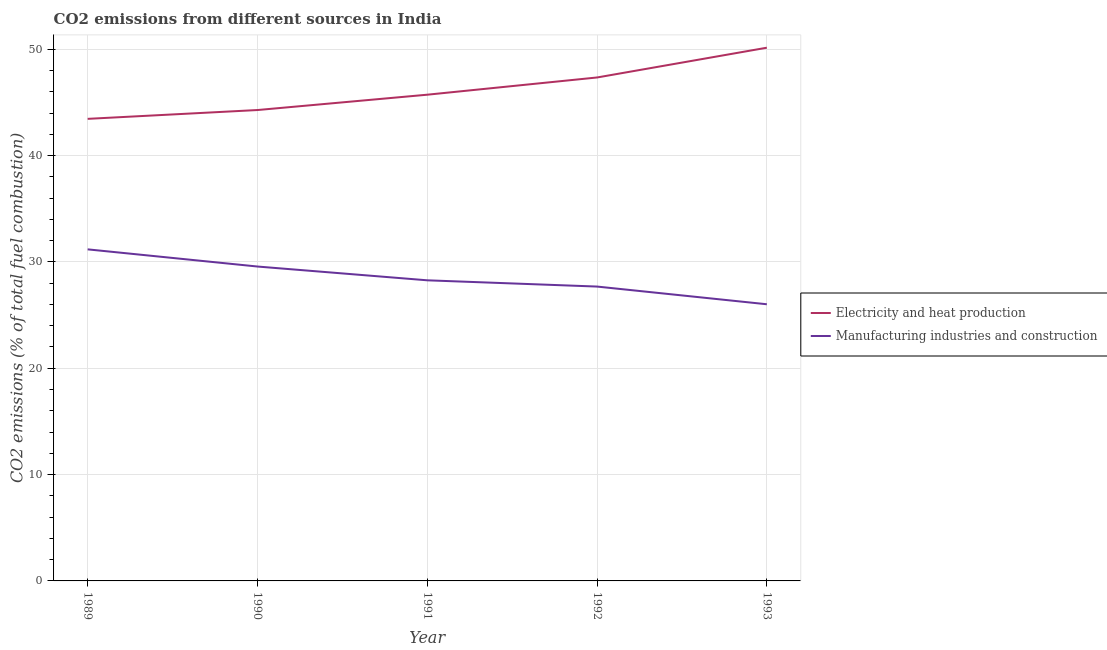How many different coloured lines are there?
Offer a terse response. 2. Does the line corresponding to co2 emissions due to electricity and heat production intersect with the line corresponding to co2 emissions due to manufacturing industries?
Your answer should be compact. No. Is the number of lines equal to the number of legend labels?
Ensure brevity in your answer.  Yes. What is the co2 emissions due to manufacturing industries in 1990?
Keep it short and to the point. 29.57. Across all years, what is the maximum co2 emissions due to electricity and heat production?
Make the answer very short. 50.15. Across all years, what is the minimum co2 emissions due to electricity and heat production?
Provide a succinct answer. 43.46. In which year was the co2 emissions due to electricity and heat production maximum?
Provide a succinct answer. 1993. In which year was the co2 emissions due to manufacturing industries minimum?
Keep it short and to the point. 1993. What is the total co2 emissions due to manufacturing industries in the graph?
Keep it short and to the point. 142.72. What is the difference between the co2 emissions due to manufacturing industries in 1989 and that in 1993?
Give a very brief answer. 5.16. What is the difference between the co2 emissions due to electricity and heat production in 1991 and the co2 emissions due to manufacturing industries in 1989?
Your answer should be very brief. 14.54. What is the average co2 emissions due to manufacturing industries per year?
Offer a terse response. 28.54. In the year 1993, what is the difference between the co2 emissions due to electricity and heat production and co2 emissions due to manufacturing industries?
Keep it short and to the point. 24.13. In how many years, is the co2 emissions due to electricity and heat production greater than 6 %?
Keep it short and to the point. 5. What is the ratio of the co2 emissions due to manufacturing industries in 1989 to that in 1991?
Offer a terse response. 1.1. Is the co2 emissions due to manufacturing industries in 1991 less than that in 1993?
Provide a short and direct response. No. Is the difference between the co2 emissions due to manufacturing industries in 1991 and 1993 greater than the difference between the co2 emissions due to electricity and heat production in 1991 and 1993?
Ensure brevity in your answer.  Yes. What is the difference between the highest and the second highest co2 emissions due to electricity and heat production?
Your answer should be very brief. 2.8. What is the difference between the highest and the lowest co2 emissions due to manufacturing industries?
Provide a short and direct response. 5.16. Is the sum of the co2 emissions due to electricity and heat production in 1990 and 1991 greater than the maximum co2 emissions due to manufacturing industries across all years?
Offer a very short reply. Yes. Is the co2 emissions due to electricity and heat production strictly greater than the co2 emissions due to manufacturing industries over the years?
Offer a terse response. Yes. How many lines are there?
Offer a very short reply. 2. What is the difference between two consecutive major ticks on the Y-axis?
Your answer should be very brief. 10. Are the values on the major ticks of Y-axis written in scientific E-notation?
Your response must be concise. No. Does the graph contain any zero values?
Your answer should be very brief. No. Where does the legend appear in the graph?
Ensure brevity in your answer.  Center right. How are the legend labels stacked?
Your answer should be compact. Vertical. What is the title of the graph?
Provide a succinct answer. CO2 emissions from different sources in India. Does "Old" appear as one of the legend labels in the graph?
Your answer should be compact. No. What is the label or title of the Y-axis?
Offer a very short reply. CO2 emissions (% of total fuel combustion). What is the CO2 emissions (% of total fuel combustion) in Electricity and heat production in 1989?
Your answer should be compact. 43.46. What is the CO2 emissions (% of total fuel combustion) in Manufacturing industries and construction in 1989?
Your answer should be very brief. 31.18. What is the CO2 emissions (% of total fuel combustion) of Electricity and heat production in 1990?
Make the answer very short. 44.28. What is the CO2 emissions (% of total fuel combustion) of Manufacturing industries and construction in 1990?
Provide a succinct answer. 29.57. What is the CO2 emissions (% of total fuel combustion) of Electricity and heat production in 1991?
Offer a terse response. 45.73. What is the CO2 emissions (% of total fuel combustion) of Manufacturing industries and construction in 1991?
Your answer should be compact. 28.27. What is the CO2 emissions (% of total fuel combustion) in Electricity and heat production in 1992?
Provide a short and direct response. 47.35. What is the CO2 emissions (% of total fuel combustion) in Manufacturing industries and construction in 1992?
Provide a short and direct response. 27.68. What is the CO2 emissions (% of total fuel combustion) in Electricity and heat production in 1993?
Offer a terse response. 50.15. What is the CO2 emissions (% of total fuel combustion) of Manufacturing industries and construction in 1993?
Your answer should be compact. 26.02. Across all years, what is the maximum CO2 emissions (% of total fuel combustion) in Electricity and heat production?
Give a very brief answer. 50.15. Across all years, what is the maximum CO2 emissions (% of total fuel combustion) in Manufacturing industries and construction?
Your response must be concise. 31.18. Across all years, what is the minimum CO2 emissions (% of total fuel combustion) of Electricity and heat production?
Make the answer very short. 43.46. Across all years, what is the minimum CO2 emissions (% of total fuel combustion) of Manufacturing industries and construction?
Your response must be concise. 26.02. What is the total CO2 emissions (% of total fuel combustion) of Electricity and heat production in the graph?
Provide a short and direct response. 230.96. What is the total CO2 emissions (% of total fuel combustion) of Manufacturing industries and construction in the graph?
Your answer should be compact. 142.72. What is the difference between the CO2 emissions (% of total fuel combustion) in Electricity and heat production in 1989 and that in 1990?
Your response must be concise. -0.83. What is the difference between the CO2 emissions (% of total fuel combustion) of Manufacturing industries and construction in 1989 and that in 1990?
Make the answer very short. 1.61. What is the difference between the CO2 emissions (% of total fuel combustion) of Electricity and heat production in 1989 and that in 1991?
Provide a succinct answer. -2.27. What is the difference between the CO2 emissions (% of total fuel combustion) of Manufacturing industries and construction in 1989 and that in 1991?
Make the answer very short. 2.91. What is the difference between the CO2 emissions (% of total fuel combustion) in Electricity and heat production in 1989 and that in 1992?
Your response must be concise. -3.89. What is the difference between the CO2 emissions (% of total fuel combustion) of Manufacturing industries and construction in 1989 and that in 1992?
Offer a very short reply. 3.5. What is the difference between the CO2 emissions (% of total fuel combustion) in Electricity and heat production in 1989 and that in 1993?
Offer a terse response. -6.69. What is the difference between the CO2 emissions (% of total fuel combustion) of Manufacturing industries and construction in 1989 and that in 1993?
Keep it short and to the point. 5.16. What is the difference between the CO2 emissions (% of total fuel combustion) in Electricity and heat production in 1990 and that in 1991?
Provide a short and direct response. -1.44. What is the difference between the CO2 emissions (% of total fuel combustion) in Manufacturing industries and construction in 1990 and that in 1991?
Provide a succinct answer. 1.3. What is the difference between the CO2 emissions (% of total fuel combustion) of Electricity and heat production in 1990 and that in 1992?
Give a very brief answer. -3.06. What is the difference between the CO2 emissions (% of total fuel combustion) of Manufacturing industries and construction in 1990 and that in 1992?
Your answer should be compact. 1.88. What is the difference between the CO2 emissions (% of total fuel combustion) of Electricity and heat production in 1990 and that in 1993?
Keep it short and to the point. -5.86. What is the difference between the CO2 emissions (% of total fuel combustion) in Manufacturing industries and construction in 1990 and that in 1993?
Your answer should be compact. 3.55. What is the difference between the CO2 emissions (% of total fuel combustion) in Electricity and heat production in 1991 and that in 1992?
Offer a very short reply. -1.62. What is the difference between the CO2 emissions (% of total fuel combustion) in Manufacturing industries and construction in 1991 and that in 1992?
Offer a very short reply. 0.59. What is the difference between the CO2 emissions (% of total fuel combustion) in Electricity and heat production in 1991 and that in 1993?
Your answer should be compact. -4.42. What is the difference between the CO2 emissions (% of total fuel combustion) in Manufacturing industries and construction in 1991 and that in 1993?
Make the answer very short. 2.25. What is the difference between the CO2 emissions (% of total fuel combustion) in Electricity and heat production in 1992 and that in 1993?
Make the answer very short. -2.8. What is the difference between the CO2 emissions (% of total fuel combustion) in Manufacturing industries and construction in 1992 and that in 1993?
Offer a very short reply. 1.66. What is the difference between the CO2 emissions (% of total fuel combustion) in Electricity and heat production in 1989 and the CO2 emissions (% of total fuel combustion) in Manufacturing industries and construction in 1990?
Offer a terse response. 13.89. What is the difference between the CO2 emissions (% of total fuel combustion) of Electricity and heat production in 1989 and the CO2 emissions (% of total fuel combustion) of Manufacturing industries and construction in 1991?
Give a very brief answer. 15.18. What is the difference between the CO2 emissions (% of total fuel combustion) of Electricity and heat production in 1989 and the CO2 emissions (% of total fuel combustion) of Manufacturing industries and construction in 1992?
Offer a terse response. 15.77. What is the difference between the CO2 emissions (% of total fuel combustion) of Electricity and heat production in 1989 and the CO2 emissions (% of total fuel combustion) of Manufacturing industries and construction in 1993?
Your answer should be very brief. 17.44. What is the difference between the CO2 emissions (% of total fuel combustion) of Electricity and heat production in 1990 and the CO2 emissions (% of total fuel combustion) of Manufacturing industries and construction in 1991?
Give a very brief answer. 16.01. What is the difference between the CO2 emissions (% of total fuel combustion) of Electricity and heat production in 1990 and the CO2 emissions (% of total fuel combustion) of Manufacturing industries and construction in 1992?
Your response must be concise. 16.6. What is the difference between the CO2 emissions (% of total fuel combustion) of Electricity and heat production in 1990 and the CO2 emissions (% of total fuel combustion) of Manufacturing industries and construction in 1993?
Make the answer very short. 18.27. What is the difference between the CO2 emissions (% of total fuel combustion) in Electricity and heat production in 1991 and the CO2 emissions (% of total fuel combustion) in Manufacturing industries and construction in 1992?
Keep it short and to the point. 18.04. What is the difference between the CO2 emissions (% of total fuel combustion) in Electricity and heat production in 1991 and the CO2 emissions (% of total fuel combustion) in Manufacturing industries and construction in 1993?
Your answer should be compact. 19.71. What is the difference between the CO2 emissions (% of total fuel combustion) of Electricity and heat production in 1992 and the CO2 emissions (% of total fuel combustion) of Manufacturing industries and construction in 1993?
Make the answer very short. 21.33. What is the average CO2 emissions (% of total fuel combustion) of Electricity and heat production per year?
Your answer should be compact. 46.19. What is the average CO2 emissions (% of total fuel combustion) of Manufacturing industries and construction per year?
Make the answer very short. 28.54. In the year 1989, what is the difference between the CO2 emissions (% of total fuel combustion) of Electricity and heat production and CO2 emissions (% of total fuel combustion) of Manufacturing industries and construction?
Your response must be concise. 12.27. In the year 1990, what is the difference between the CO2 emissions (% of total fuel combustion) in Electricity and heat production and CO2 emissions (% of total fuel combustion) in Manufacturing industries and construction?
Ensure brevity in your answer.  14.72. In the year 1991, what is the difference between the CO2 emissions (% of total fuel combustion) in Electricity and heat production and CO2 emissions (% of total fuel combustion) in Manufacturing industries and construction?
Offer a terse response. 17.46. In the year 1992, what is the difference between the CO2 emissions (% of total fuel combustion) in Electricity and heat production and CO2 emissions (% of total fuel combustion) in Manufacturing industries and construction?
Ensure brevity in your answer.  19.66. In the year 1993, what is the difference between the CO2 emissions (% of total fuel combustion) of Electricity and heat production and CO2 emissions (% of total fuel combustion) of Manufacturing industries and construction?
Your response must be concise. 24.13. What is the ratio of the CO2 emissions (% of total fuel combustion) in Electricity and heat production in 1989 to that in 1990?
Your response must be concise. 0.98. What is the ratio of the CO2 emissions (% of total fuel combustion) in Manufacturing industries and construction in 1989 to that in 1990?
Provide a succinct answer. 1.05. What is the ratio of the CO2 emissions (% of total fuel combustion) in Electricity and heat production in 1989 to that in 1991?
Ensure brevity in your answer.  0.95. What is the ratio of the CO2 emissions (% of total fuel combustion) in Manufacturing industries and construction in 1989 to that in 1991?
Offer a very short reply. 1.1. What is the ratio of the CO2 emissions (% of total fuel combustion) in Electricity and heat production in 1989 to that in 1992?
Provide a succinct answer. 0.92. What is the ratio of the CO2 emissions (% of total fuel combustion) of Manufacturing industries and construction in 1989 to that in 1992?
Ensure brevity in your answer.  1.13. What is the ratio of the CO2 emissions (% of total fuel combustion) in Electricity and heat production in 1989 to that in 1993?
Offer a terse response. 0.87. What is the ratio of the CO2 emissions (% of total fuel combustion) of Manufacturing industries and construction in 1989 to that in 1993?
Your response must be concise. 1.2. What is the ratio of the CO2 emissions (% of total fuel combustion) in Electricity and heat production in 1990 to that in 1991?
Your answer should be very brief. 0.97. What is the ratio of the CO2 emissions (% of total fuel combustion) in Manufacturing industries and construction in 1990 to that in 1991?
Ensure brevity in your answer.  1.05. What is the ratio of the CO2 emissions (% of total fuel combustion) of Electricity and heat production in 1990 to that in 1992?
Your response must be concise. 0.94. What is the ratio of the CO2 emissions (% of total fuel combustion) of Manufacturing industries and construction in 1990 to that in 1992?
Keep it short and to the point. 1.07. What is the ratio of the CO2 emissions (% of total fuel combustion) of Electricity and heat production in 1990 to that in 1993?
Your response must be concise. 0.88. What is the ratio of the CO2 emissions (% of total fuel combustion) in Manufacturing industries and construction in 1990 to that in 1993?
Provide a succinct answer. 1.14. What is the ratio of the CO2 emissions (% of total fuel combustion) in Electricity and heat production in 1991 to that in 1992?
Offer a very short reply. 0.97. What is the ratio of the CO2 emissions (% of total fuel combustion) of Manufacturing industries and construction in 1991 to that in 1992?
Make the answer very short. 1.02. What is the ratio of the CO2 emissions (% of total fuel combustion) of Electricity and heat production in 1991 to that in 1993?
Your answer should be compact. 0.91. What is the ratio of the CO2 emissions (% of total fuel combustion) in Manufacturing industries and construction in 1991 to that in 1993?
Give a very brief answer. 1.09. What is the ratio of the CO2 emissions (% of total fuel combustion) of Electricity and heat production in 1992 to that in 1993?
Ensure brevity in your answer.  0.94. What is the ratio of the CO2 emissions (% of total fuel combustion) of Manufacturing industries and construction in 1992 to that in 1993?
Offer a terse response. 1.06. What is the difference between the highest and the second highest CO2 emissions (% of total fuel combustion) in Electricity and heat production?
Your answer should be very brief. 2.8. What is the difference between the highest and the second highest CO2 emissions (% of total fuel combustion) of Manufacturing industries and construction?
Provide a short and direct response. 1.61. What is the difference between the highest and the lowest CO2 emissions (% of total fuel combustion) of Electricity and heat production?
Your response must be concise. 6.69. What is the difference between the highest and the lowest CO2 emissions (% of total fuel combustion) of Manufacturing industries and construction?
Offer a very short reply. 5.16. 